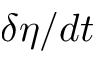Convert formula to latex. <formula><loc_0><loc_0><loc_500><loc_500>\delta \eta / d t</formula> 